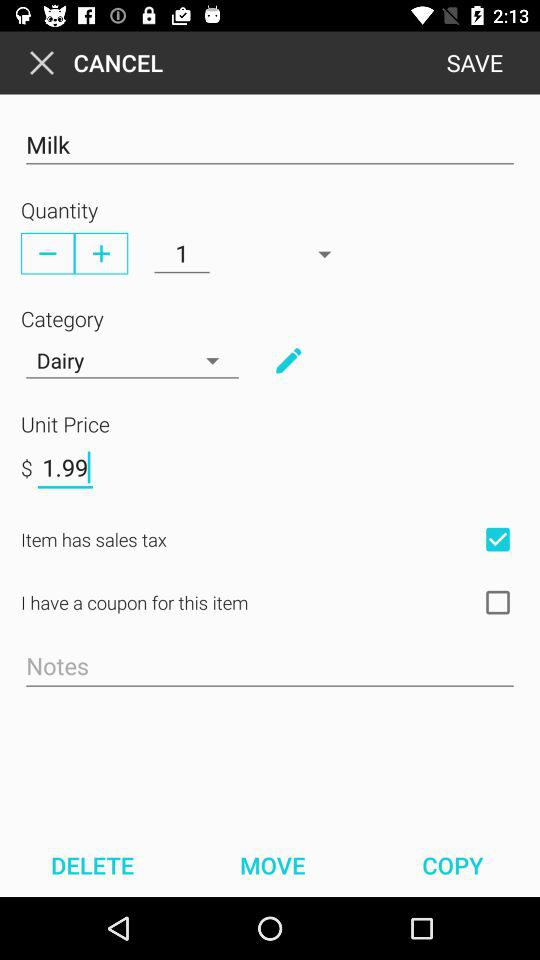What is written in the notes?
When the provided information is insufficient, respond with <no answer>. <no answer> 